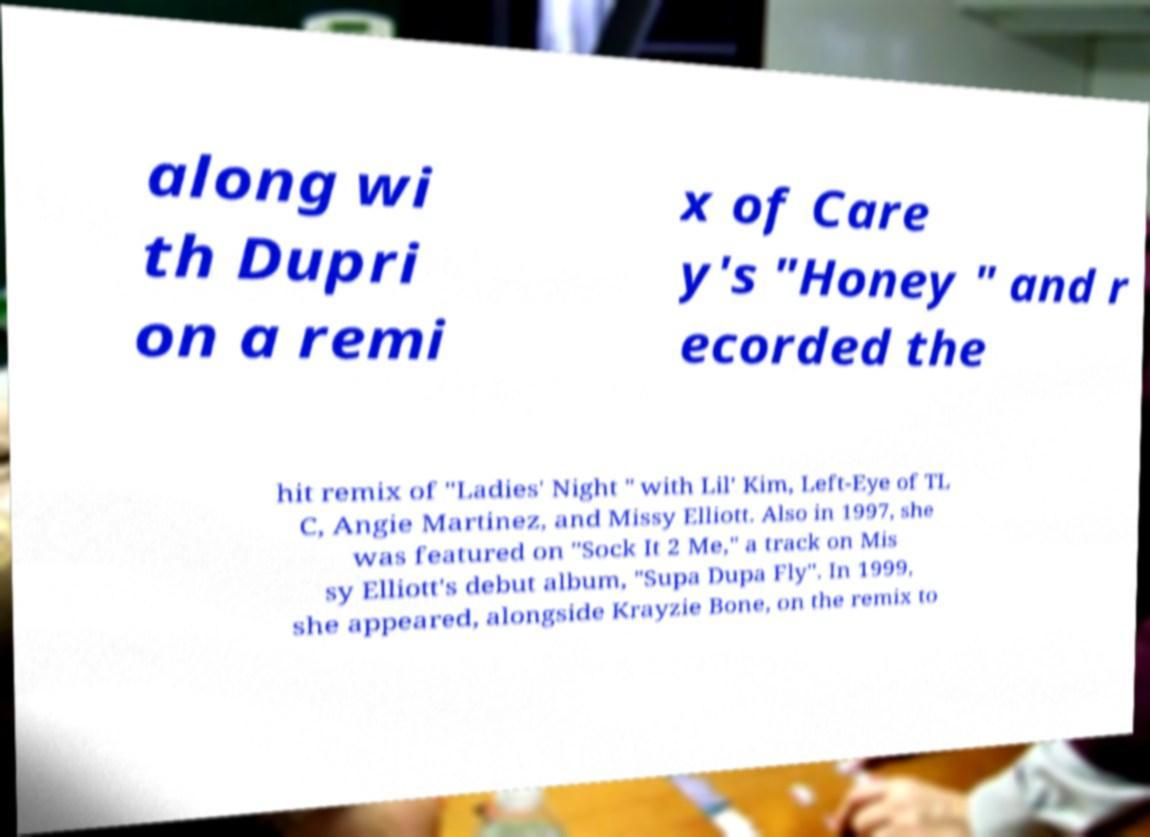What messages or text are displayed in this image? I need them in a readable, typed format. along wi th Dupri on a remi x of Care y's "Honey " and r ecorded the hit remix of "Ladies' Night " with Lil' Kim, Left-Eye of TL C, Angie Martinez, and Missy Elliott. Also in 1997, she was featured on "Sock It 2 Me," a track on Mis sy Elliott's debut album, "Supa Dupa Fly". In 1999, she appeared, alongside Krayzie Bone, on the remix to 